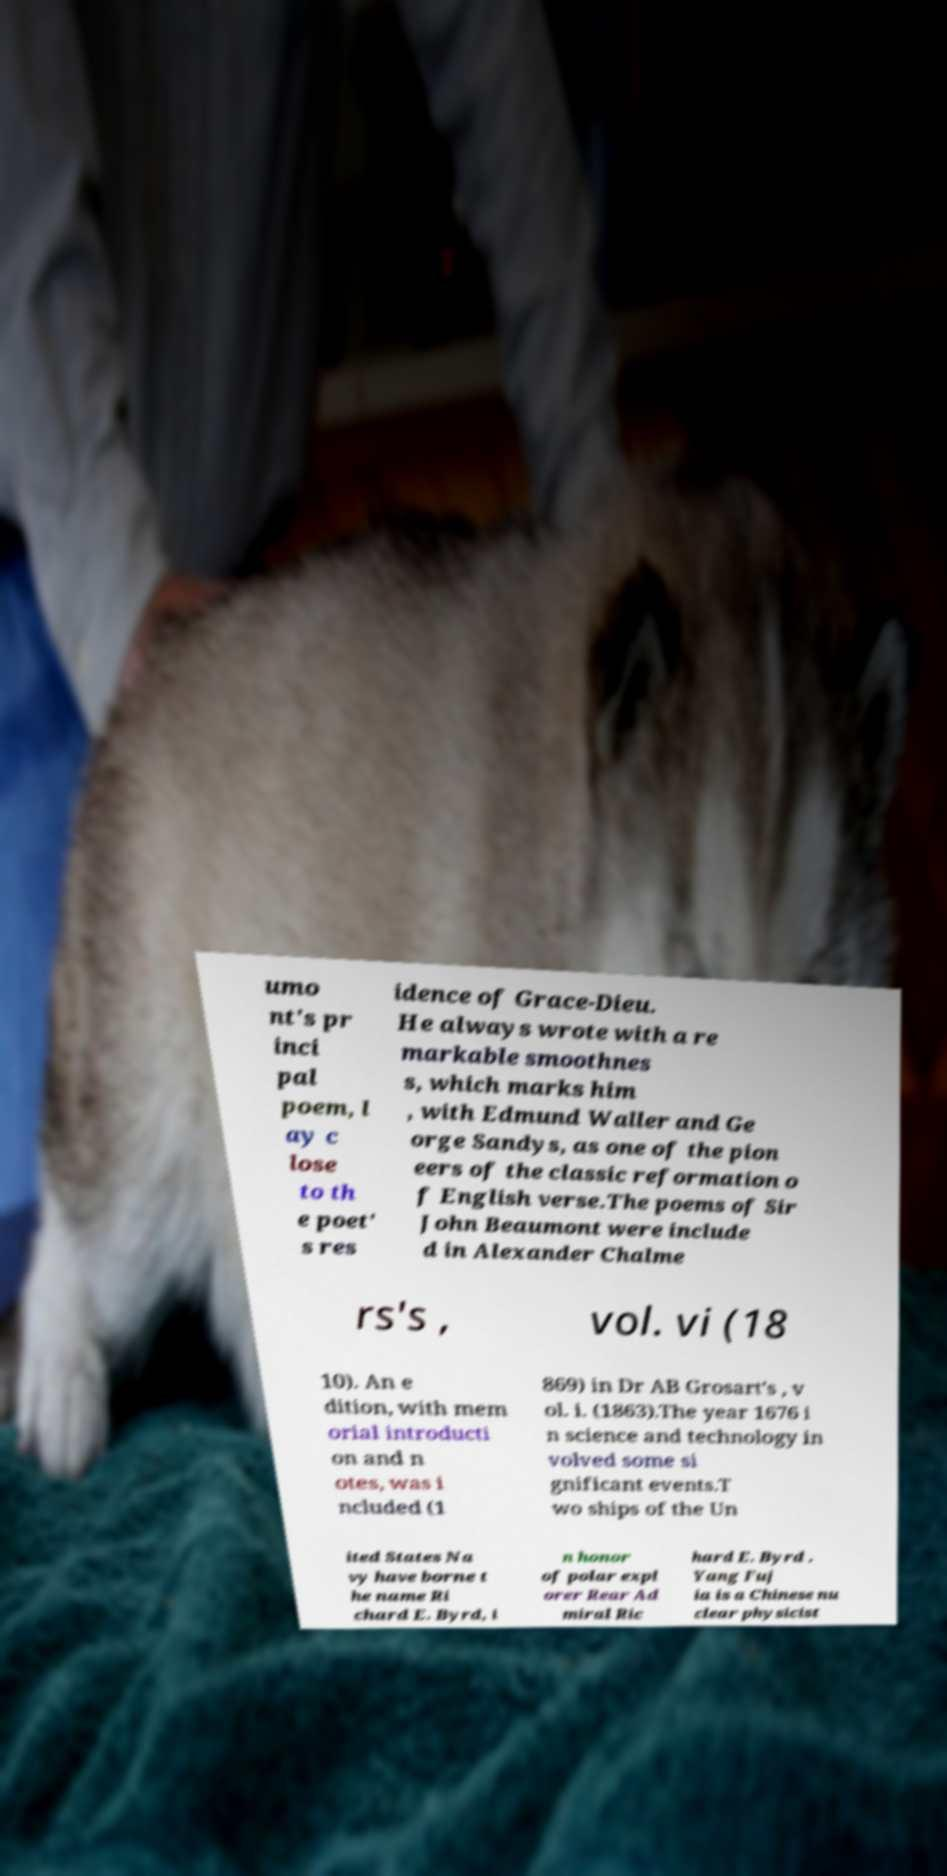For documentation purposes, I need the text within this image transcribed. Could you provide that? umo nt's pr inci pal poem, l ay c lose to th e poet' s res idence of Grace-Dieu. He always wrote with a re markable smoothnes s, which marks him , with Edmund Waller and Ge orge Sandys, as one of the pion eers of the classic reformation o f English verse.The poems of Sir John Beaumont were include d in Alexander Chalme rs's , vol. vi (18 10). An e dition, with mem orial introducti on and n otes, was i ncluded (1 869) in Dr AB Grosart's , v ol. i. (1863).The year 1676 i n science and technology in volved some si gnificant events.T wo ships of the Un ited States Na vy have borne t he name Ri chard E. Byrd, i n honor of polar expl orer Rear Ad miral Ric hard E. Byrd . Yang Fuj ia is a Chinese nu clear physicist 